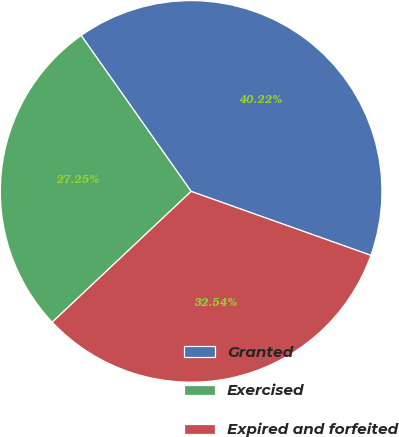<chart> <loc_0><loc_0><loc_500><loc_500><pie_chart><fcel>Granted<fcel>Exercised<fcel>Expired and forfeited<nl><fcel>40.22%<fcel>27.25%<fcel>32.54%<nl></chart> 